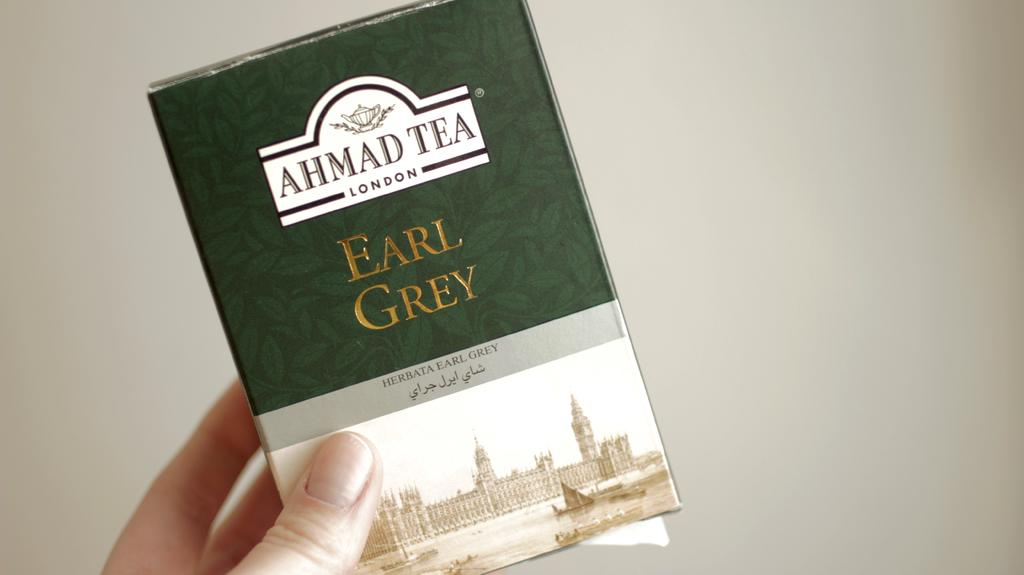<image>
Offer a succinct explanation of the picture presented. Tea from the maker Ahmad Tea in London in Earl Grey flavor. 